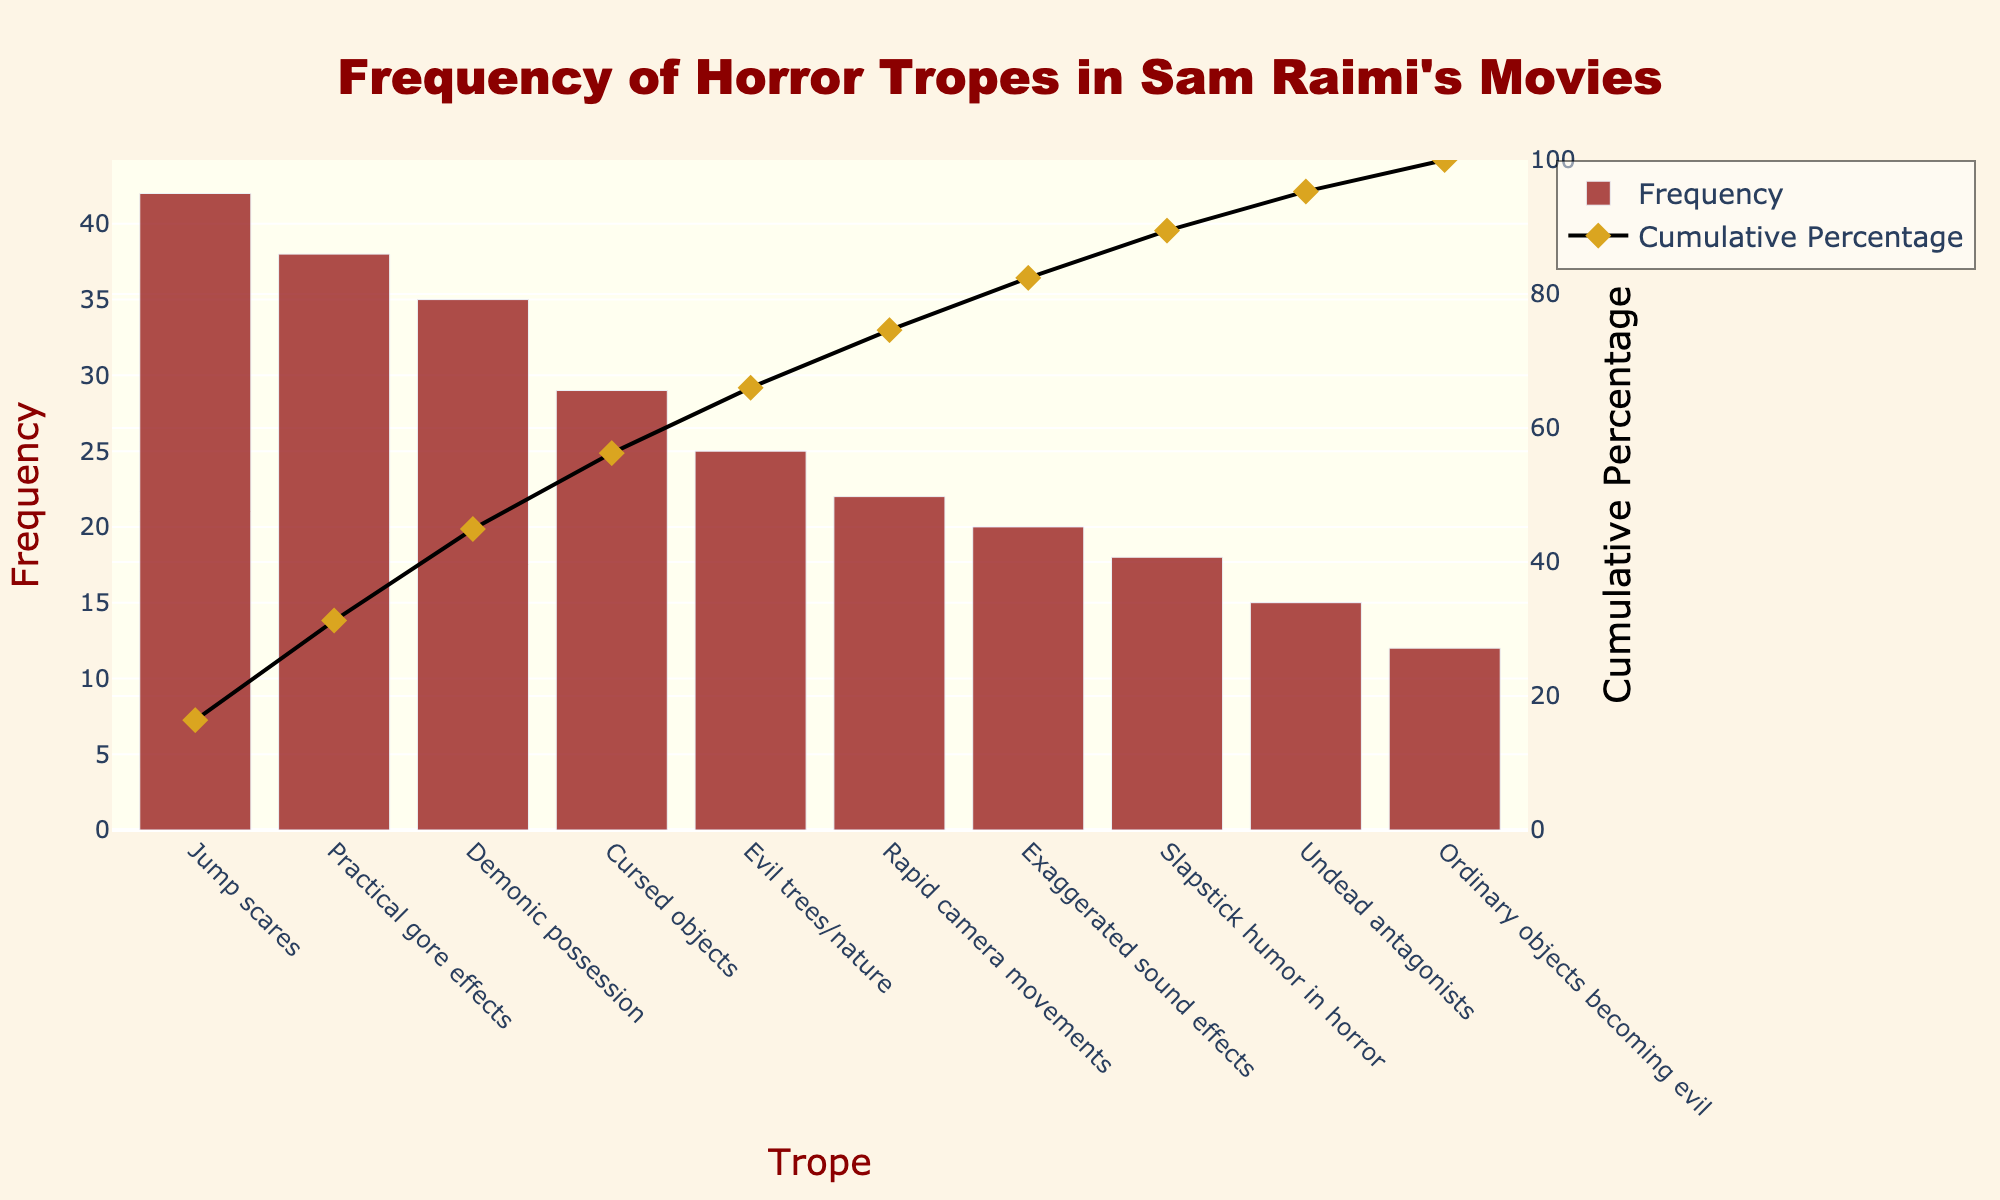How many data points are shown in the figure? The figure lists multiple horror tropes along with their frequencies. Simply counting the number of unique tropes gives us the total number of data points.
Answer: 10 Which horror trope has the highest frequency in Sam Raimi’s movies? Look at the bar with the highest value on the y-axis of Frequency, identifying the corresponding trope.
Answer: Jump scares What is the cumulative percentage for "Demonic possession"? Locate "Demonic possession" on the x-axis and track the corresponding point on the line marking the cumulative percentage.
Answer: 73.33% Which trope has the lowest frequency and what is its value? Find the bar corresponding to the lowest value on the Frequency axis and identify the associated trope.
Answer: Ordinary objects becoming evil, 12 How much higher is the frequency of "Practical gore effects" compared to "Ordinary objects becoming evil"? Subtract the frequency of "Ordinary objects becoming evil" from the frequency of "Practical gore effects". 38 - 12 = 26.
Answer: 26 What's the cumulative percentage after the third highest trope by frequency? Identify the third highest trope in terms of frequency which is "Demonic possession" and look at its cumulative percentage.
Answer: 73.33% What percentage of the total do the top three tropes represent? To get the percentage, sum the frequencies of the top three tropes and then divide by the total frequency sum, then multiply by 100. (42 + 38 + 35) / (42 + 38 + 35 + 29 + 25 + 22 + 20 + 18 + 15 + 12) * 100 = 115 / 256 * 100 = 44.92%
Answer: 44.92% Which horror trope has a frequency closest to the average frequency of all tropes? Calculate the average frequency by summing all frequencies and dividing by the number of tropes, then identify the trope whose frequency is closest to this average. Average = 256 / 10 = 25.6, closest to "Evil trees/nature" with a frequency of 25.
Answer: Evil trees/nature What is the cumulative percentage after the "Rapid camera movements" trope? Locate "Rapid camera movements" on the x-axis and check its corresponding cumulative percentage on the line graph.
Answer: 80.86% Is "Slapstick humor in horror" used more frequently than "Undead antagonists"? Compare the height of the bars corresponding to "Slapstick humor in horror" and "Undead antagonists".
Answer: Yes 